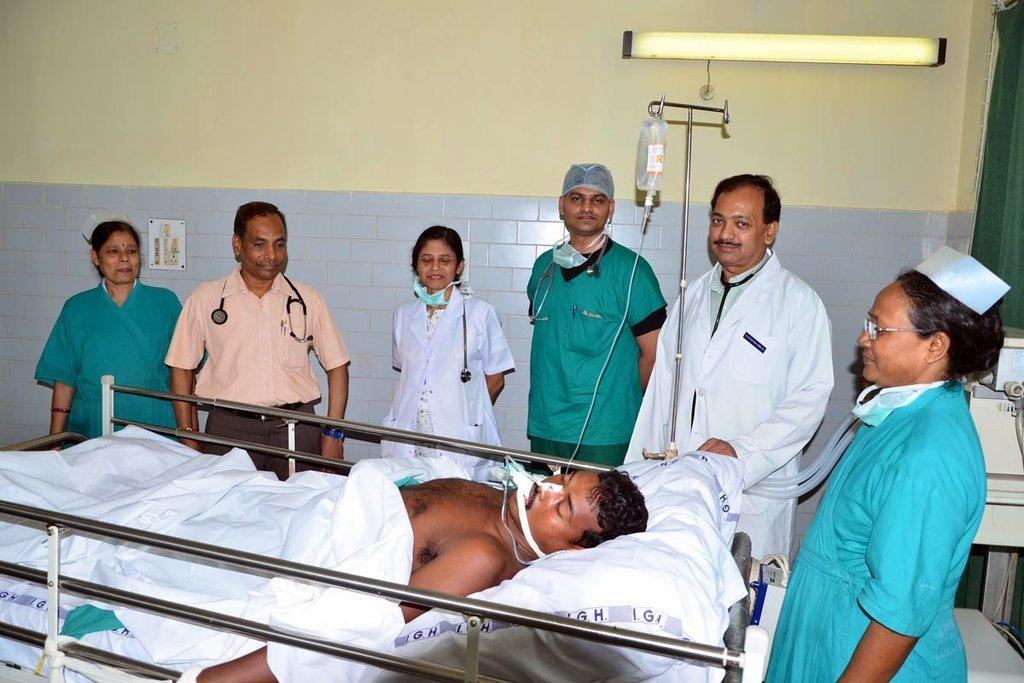How would you summarize this image in a sentence or two? In the image we can see there are people standing and one is lying, they are wearing clothes. Here we can see stethoscope and a hanger, on the hanger there is a bottle hanged. Here we can see the light, wall and the switchboard. 